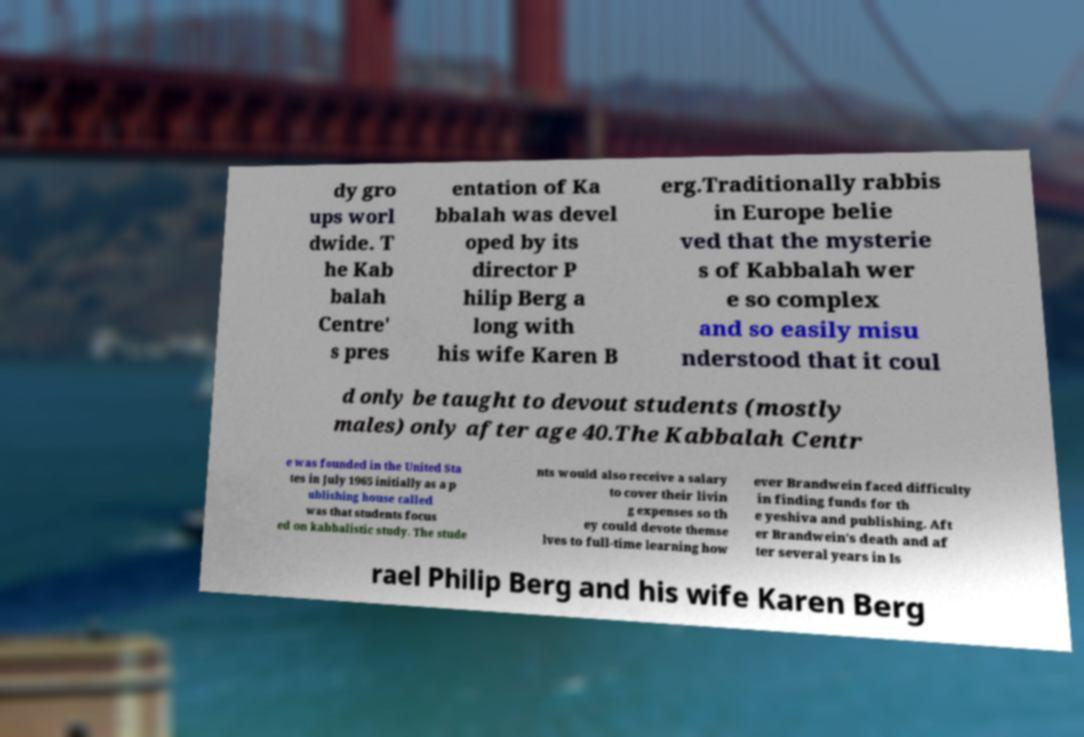Can you read and provide the text displayed in the image?This photo seems to have some interesting text. Can you extract and type it out for me? dy gro ups worl dwide. T he Kab balah Centre' s pres entation of Ka bbalah was devel oped by its director P hilip Berg a long with his wife Karen B erg.Traditionally rabbis in Europe belie ved that the mysterie s of Kabbalah wer e so complex and so easily misu nderstood that it coul d only be taught to devout students (mostly males) only after age 40.The Kabbalah Centr e was founded in the United Sta tes in July 1965 initially as a p ublishing house called was that students focus ed on kabbalistic study. The stude nts would also receive a salary to cover their livin g expenses so th ey could devote themse lves to full-time learning how ever Brandwein faced difficulty in finding funds for th e yeshiva and publishing. Aft er Brandwein's death and af ter several years in Is rael Philip Berg and his wife Karen Berg 